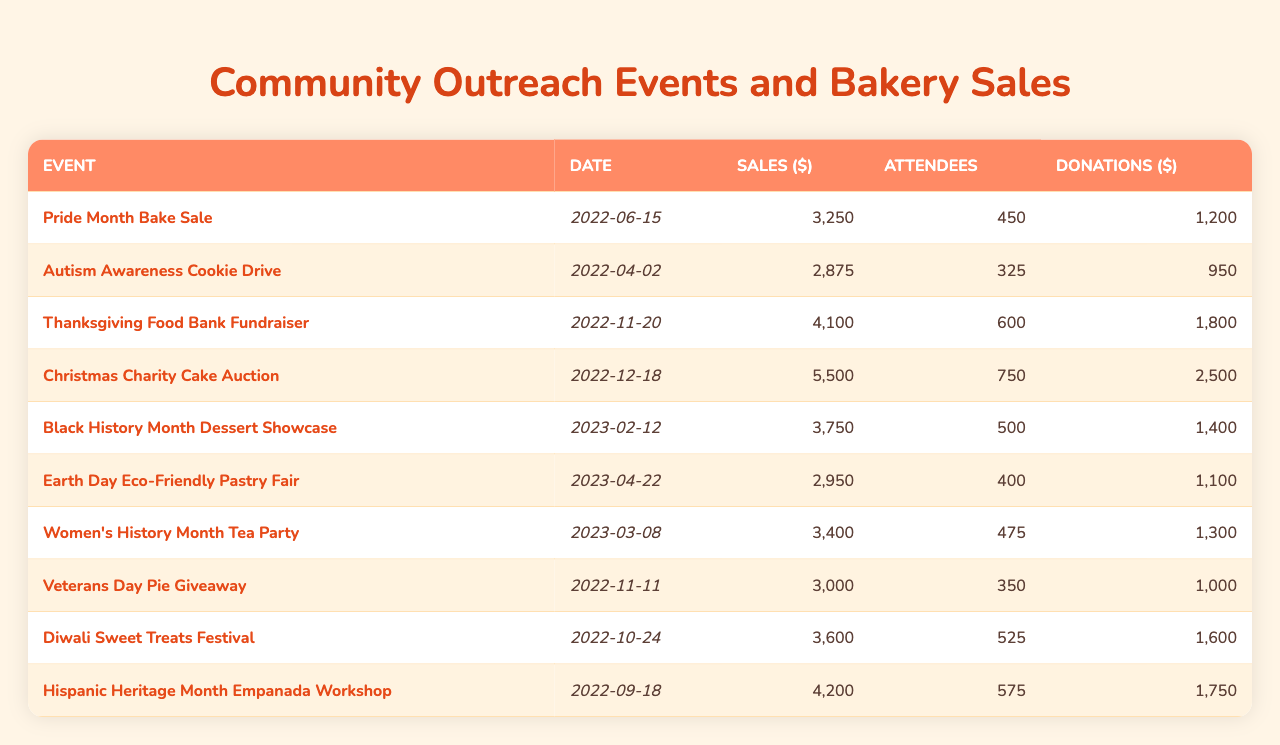What was the total sales amount from all events? To find the total sales amount, sum the sales figures for each event: 3250 + 2875 + 4100 + 5500 + 3750 + 2950 + 3400 + 3000 + 3600 + 4200 =  34,625
Answer: 34625 Which event had the highest attendance? The highest attendance can be found by comparing the number of attendees for each event. The Thanksgiving Food Bank Fundraiser had 600 attendees, which is the highest.
Answer: Thanksgiving Food Bank Fundraiser What are the sales for the Christmas Charity Cake Auction? The sales can be retrieved directly from the table for the Christmas Charity Cake Auction, which shows $5500.
Answer: 5500 How much was donated during the Pride Month Bake Sale? The donations for the Pride Month Bake Sale can be found in the corresponding column, which lists $1200.
Answer: 1200 What was the average number of attendees across all events? To calculate the average number of attendees, sum the attendees first: 450 + 325 + 600 + 750 + 500 + 400 + 475 + 350 + 525 + 575 = 4250. Then divide by the number of events, which is 10, so 4250 / 10 = 425.
Answer: 425 Is it true that the earnings from the Black History Month Dessert Showcase were greater than the amount donated for the Diwali Sweet Treats Festival? The sales for Black History Month Dessert Showcase are $3750 while the donations for Diwali Sweet Treats Festival are $1600. Since 3750 > 1600, the statement is true.
Answer: True Which event generated the most donations? By checking the donations for each event, the Christmas Charity Cake Auction had the highest amount of $2500.
Answer: Christmas Charity Cake Auction What is the difference in sales between the event with the least and most sales? First, identify the least sales, which is $2875 (for Autism Awareness Cookie Drive) and the highest sales, which is $5500 (for Christmas Charity Cake Auction). Calculate the difference: 5500 - 2875 = 2625.
Answer: 2625 How many events had sales above $4000? First, we look at each sales figure and count how many exceed $4000: Christmas Charity Cake Auction ($5500), Thanksgiving Food Bank Fundraiser ($4100), and Diwali Sweet Treats Festival ($4200), totaling 3 events.
Answer: 3 What was the ratio of total sales to total donations across all events? First, calculate total sales (34,625) and total donations (12,300 = 1200 + 950 + 1800 + 2500 + 1400 + 1100 + 1300 + 1000 + 1600 + 1750). Then calculate the ratio: 34,625 / 12,300 ≈ 2.81.
Answer: 2.81 